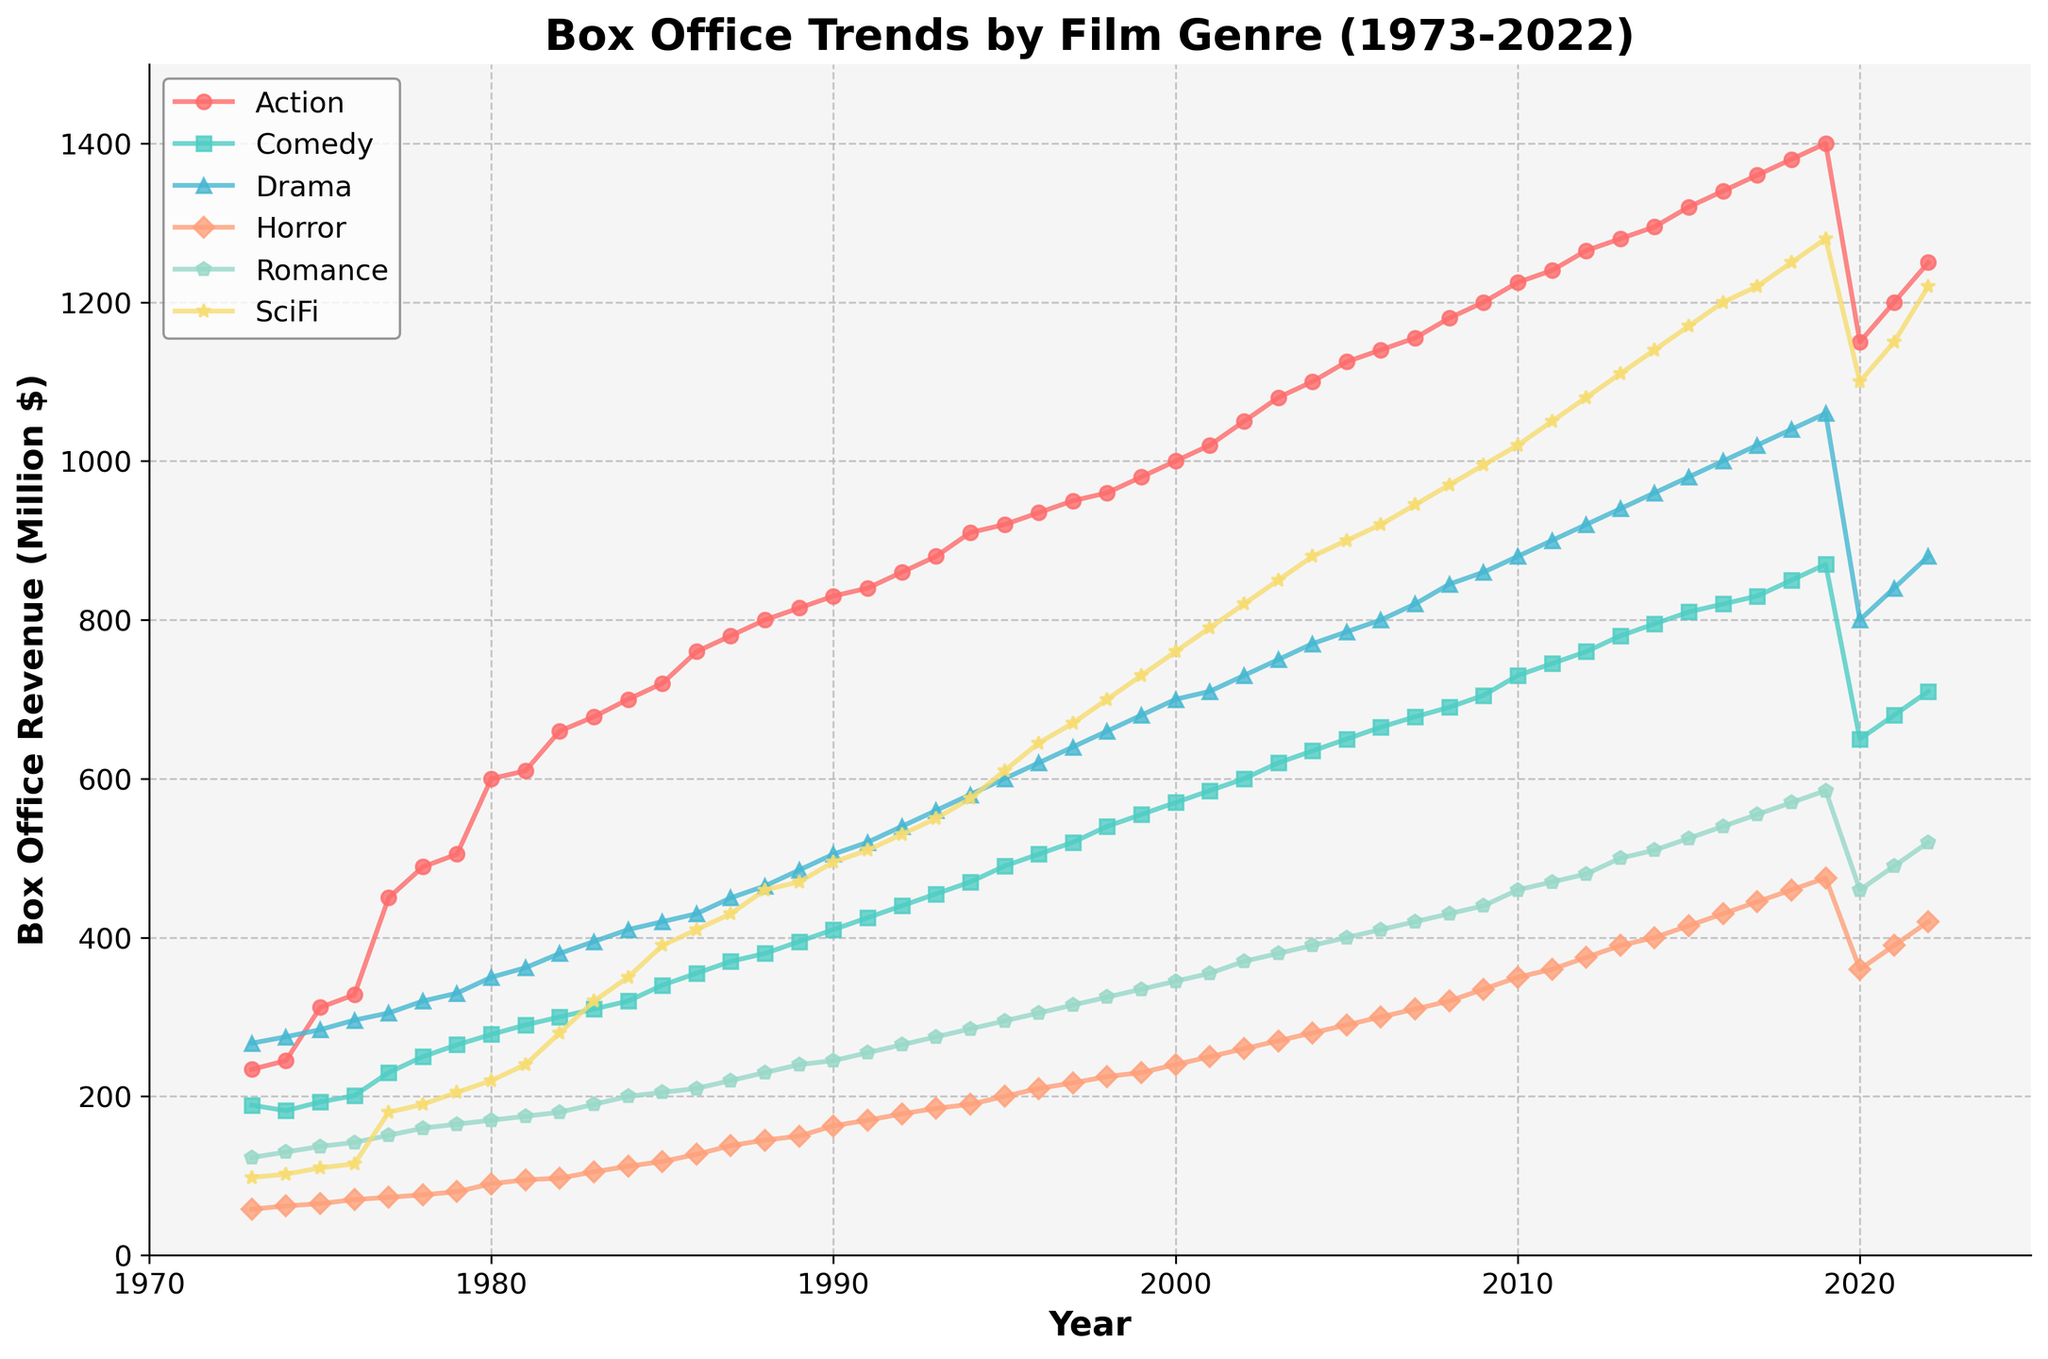What is the title of the plot? The title of the plot is displayed at the top of the figure in bold text. It summarizes the main content of the plot.
Answer: Box Office Trends by Film Genre (1973-2022) Which two genres show the highest box office revenue in 2022? To determine this, look at the endpoints of the lines in the plot at the year 2022 and identify the two highest points.
Answer: Action and SciFi What is the lowest box office revenue genre in 1973, and what is its value? Check the plot for the year 1973 and find the lowest point among all the genres presented.
Answer: Horror, 58 By how much did the box office revenue for Action films increase from 1980 to 1990? Find the value for Action films in 1980 and 1990, then subtract the 1980 value from the 1990 value.
Answer: 230 Which genre experienced the most dramatic drop in box office revenue in 2020? Look at the plot around the year 2020 and identify the genre with the steepest decline from the previous year.
Answer: Action Around what year did SciFi films start to surpass Drama films in box office revenue? Follow the SciFi and Drama lines and look for the intersection point where SciFi starts to exceed Drama.
Answer: Around 1995 What was the box office revenue trend for Comedy films from 2005 to 2020? Observe the Comedy line from 2005 to 2020 to describe whether it generally increased, decreased, or had fluctuations.
Answer: Fluctuating with a slight decline in 2020 Between 1977 and 1987, which genre showed consistent growth every year? Look at each genre line segment between 1977 and 1987 and observe which one always trends upward without any dips.
Answer: Action In which decade did the Romance genre see the most significant rise in box office revenue? Identify the decade by looking at the trend and comparing the slopes of the Romance line for each decade.
Answer: 2010s Which genre reached a box office revenue of around 600 million dollars first, and in what year? Follow the lines to see which genre hits the 600 million dollar y-axis point first and note the corresponding year.
Answer: Drama, around 1995 